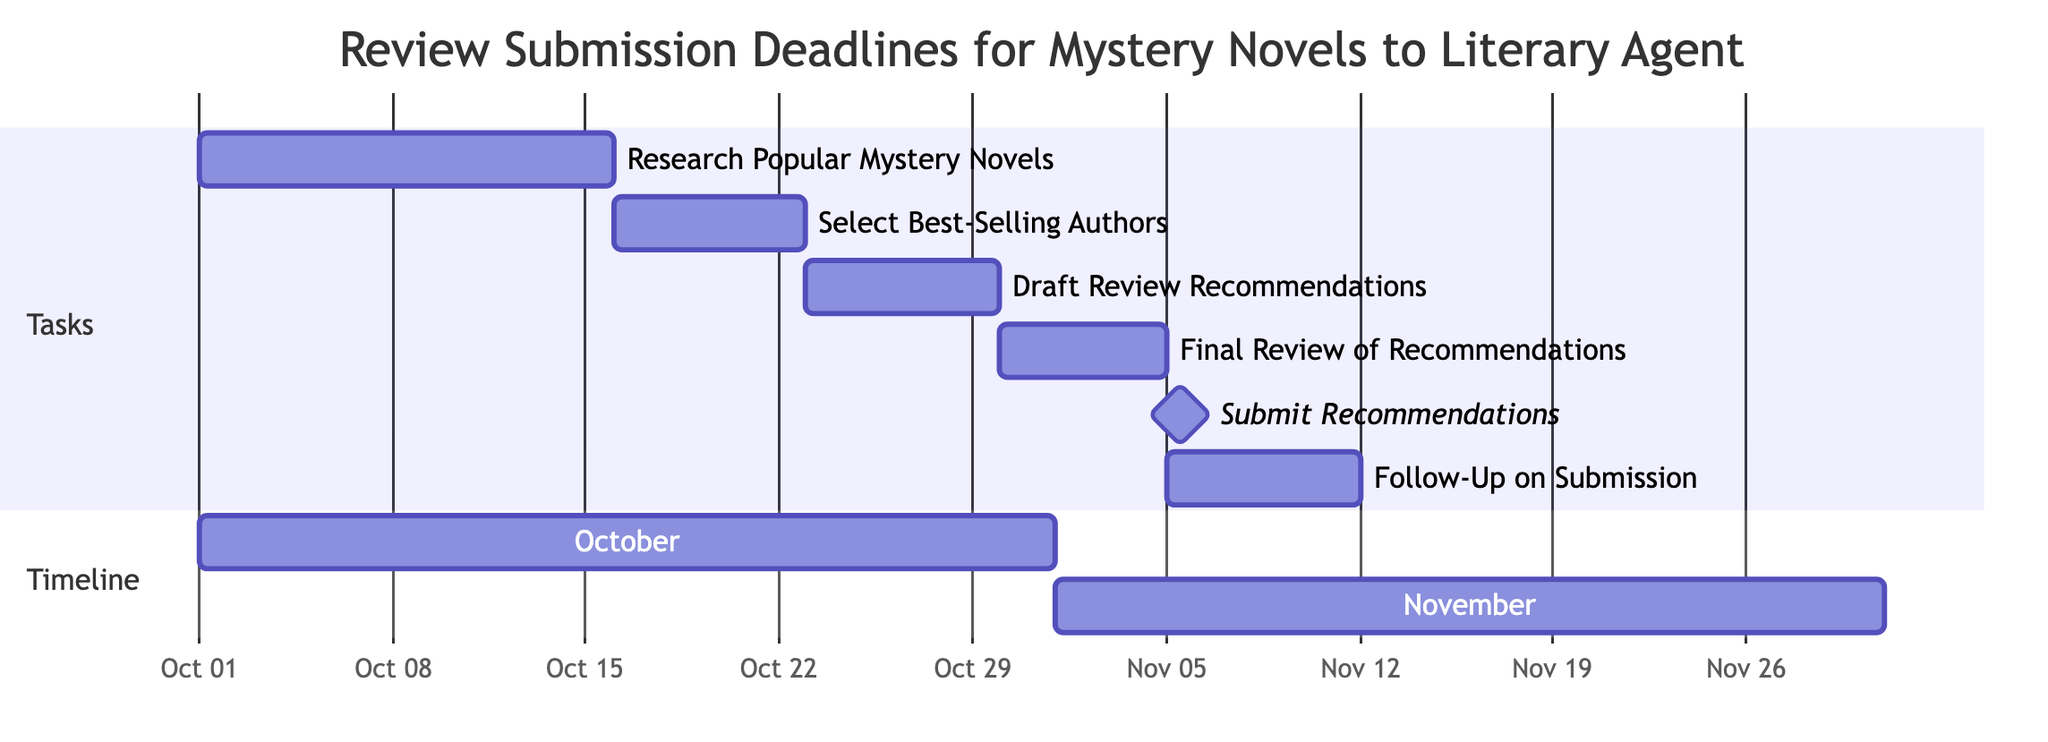What is the duration of the task "Research Popular Mystery Novels"? The task "Research Popular Mystery Novels" starts on October 1, 2023, and ends on October 15, 2023. This gives it a duration of 15 days.
Answer: 15 days What task follows "Draft Review Submission Recommendations"? The task "Final Review of Recommendations" follows "Draft Review Submission Recommendations." It is indicated as occurring directly after the previous task on the Gantt chart.
Answer: Final Review of Recommendations How many tasks are there in total? The diagram lists six distinct tasks under the section "Tasks." Counting them gives a total of six tasks.
Answer: 6 What is the starting date for the task "Submit Recommendations to Literary Agent"? The "Submit Recommendations to Literary Agent" task starts on November 5, 2023, as it is marked in the Gantt chart under the appropriate section.
Answer: November 5, 2023 Which task has the shortest duration? The "Submit Recommendations" task has the shortest duration, lasting only 1 day. This duration is noted as a milestone in the chart.
Answer: Submit Recommendations What is the ending date of "Follow-Up on Submission"? The "Follow-Up on Submission" task starts on November 6, 2023, and lasts for 7 days, ending on November 12, 2023. This can be calculated from the task's stated duration.
Answer: November 12, 2023 What is the total time frame covered by the timeline in the diagram? The Gantt chart presents tasks spanning from October 1, 2023, to November 12, 2023. The time frame spans 6 weeks, starting in October and ending in November.
Answer: 6 weeks What is the relationship between "Select Best-Selling Authors to Recommend" and "Draft Review Submission Recommendations"? "Select Best-Selling Authors to Recommend" occurs directly before "Draft Review Submission Recommendations," meaning it must be completed before starting the next task.
Answer: Sequential relationship 